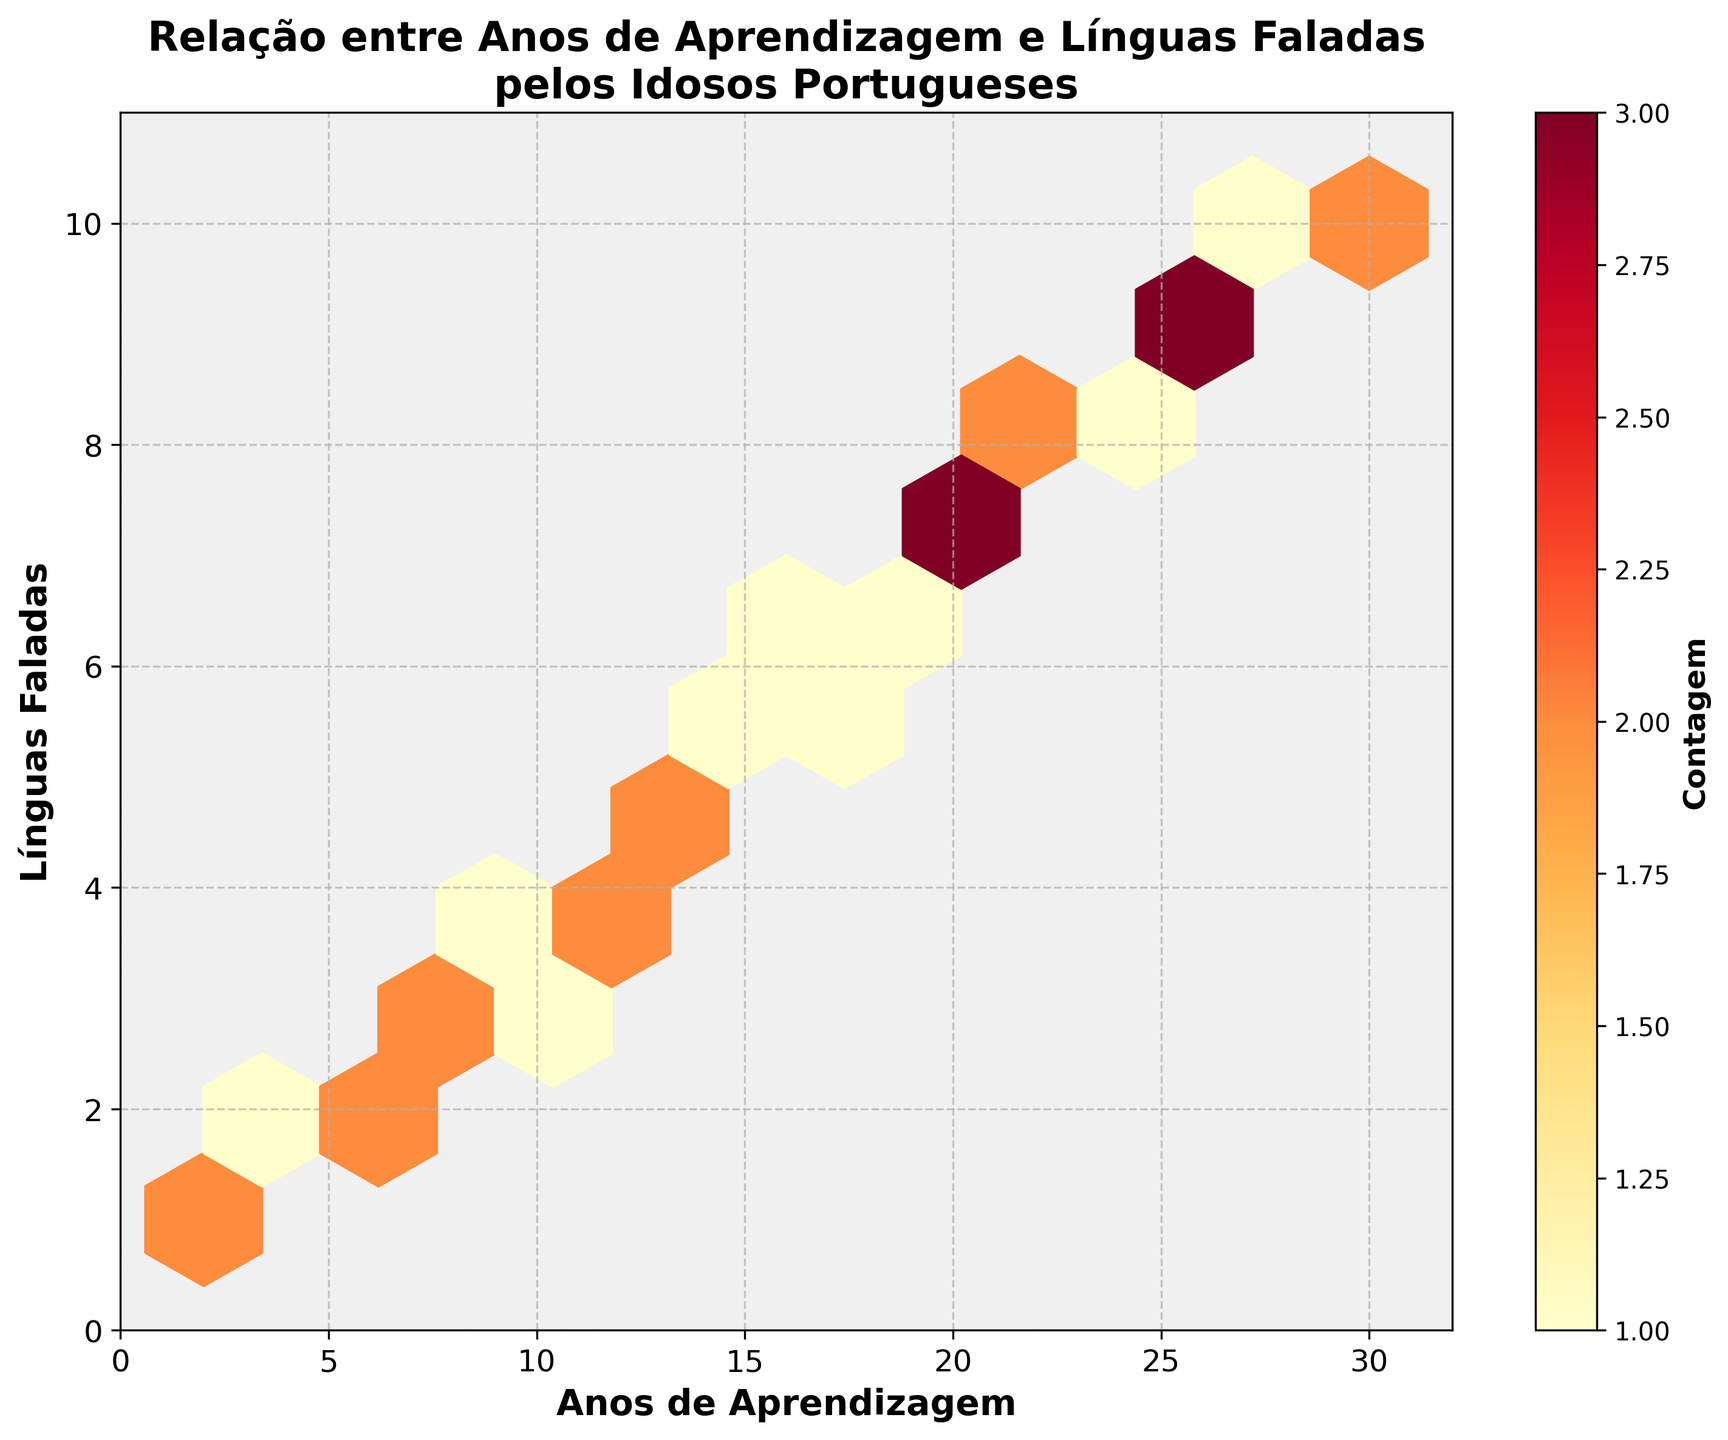What's the title of the plot? The title is at the top of the figure, prominently displayed in bold letters.
Answer: Relação entre Anos de Aprendizagem e Línguas Faladas pelos Idosos Portugueses How many years of learning languages are shown on the x-axis? The x-axis represents the "Anos de Aprendizagem" and ranges from 0 to 32.
Answer: 32 years What is the color representing the highest density of data points? In a hexbin plot, colors represent the density of data points. The highest density is shown in the brightest or most intense color, which is typically in the 'YlOrRd' colormap.
Answer: Brightest Yellow What is the maximum number of languages spoken according to the y-axis? The y-axis represents "Línguas Faladas" and indicates the highest value shown on the axis.
Answer: 10 languages How many data points are shown where seniors have more than 20 years of language learning? By observing the hexagons positioned beyond the 20-year mark on the x-axis, count the individual hexagons.
Answer: 10 points What is the most frequent count of languages spoken by seniors who have studied languages for between 10 and 20 years? Review the hexagons within the 10-20 year range on the x-axis, and identify the color or intensity indicating the highest frequency.
Answer: 4 to 6 languages Which data point range shows the highest density of learning years and number of languages spoken? Identify the brightest hexagon area within the plot, representing the highest data concentration.
Answer: 6-10 years and 2-4 languages Is there a positive correlation between years of learning and the number of languages spoken? A positive correlation implies that as one variable increases, the other does too. Observe if the plot generally trends upward from left to right.
Answer: Yes What is the average number of languages spoken by those with exactly 15 years of learning? Identify the hexagons at the 15-year mark on the x-axis and approximate the range of languages spoken represented by their colors. Calculate the midpoint.
Answer: Approximately 5 languages Are there any outliers in the data? If so, where are they located? Outliers are data points that do not fit the general pattern. Observe any lone hexagons far from the main trend.
Answer: Yes, around 30 years and 10 languages 